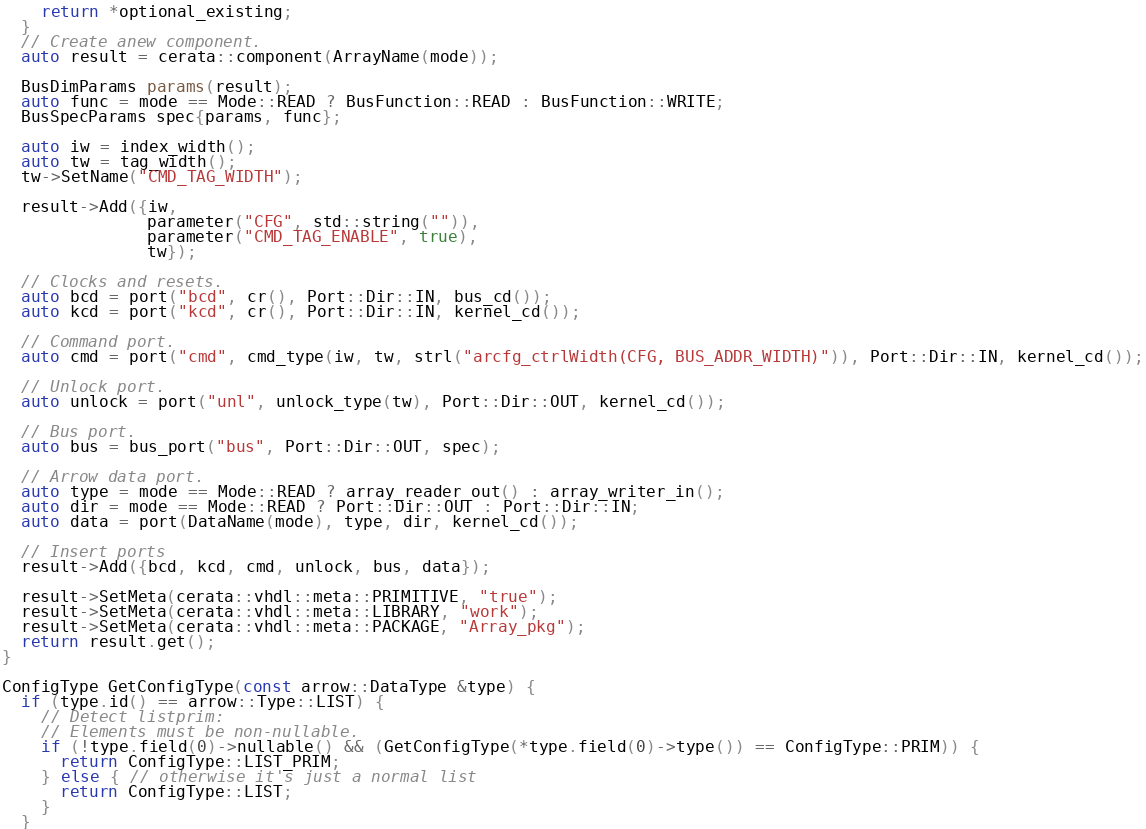Convert code to text. <code><loc_0><loc_0><loc_500><loc_500><_C++_>    return *optional_existing;
  }
  // Create anew component.
  auto result = cerata::component(ArrayName(mode));

  BusDimParams params(result);
  auto func = mode == Mode::READ ? BusFunction::READ : BusFunction::WRITE;
  BusSpecParams spec{params, func};

  auto iw = index_width();
  auto tw = tag_width();
  tw->SetName("CMD_TAG_WIDTH");

  result->Add({iw,
               parameter("CFG", std::string("")),
               parameter("CMD_TAG_ENABLE", true),
               tw});

  // Clocks and resets.
  auto bcd = port("bcd", cr(), Port::Dir::IN, bus_cd());
  auto kcd = port("kcd", cr(), Port::Dir::IN, kernel_cd());

  // Command port.
  auto cmd = port("cmd", cmd_type(iw, tw, strl("arcfg_ctrlWidth(CFG, BUS_ADDR_WIDTH)")), Port::Dir::IN, kernel_cd());

  // Unlock port.
  auto unlock = port("unl", unlock_type(tw), Port::Dir::OUT, kernel_cd());

  // Bus port.
  auto bus = bus_port("bus", Port::Dir::OUT, spec);

  // Arrow data port.
  auto type = mode == Mode::READ ? array_reader_out() : array_writer_in();
  auto dir = mode == Mode::READ ? Port::Dir::OUT : Port::Dir::IN;
  auto data = port(DataName(mode), type, dir, kernel_cd());

  // Insert ports
  result->Add({bcd, kcd, cmd, unlock, bus, data});

  result->SetMeta(cerata::vhdl::meta::PRIMITIVE, "true");
  result->SetMeta(cerata::vhdl::meta::LIBRARY, "work");
  result->SetMeta(cerata::vhdl::meta::PACKAGE, "Array_pkg");
  return result.get();
}

ConfigType GetConfigType(const arrow::DataType &type) {
  if (type.id() == arrow::Type::LIST) {
    // Detect listprim:
    // Elements must be non-nullable.
    if (!type.field(0)->nullable() && (GetConfigType(*type.field(0)->type()) == ConfigType::PRIM)) {
      return ConfigType::LIST_PRIM;
    } else { // otherwise it's just a normal list
      return ConfigType::LIST;
    }
  }</code> 